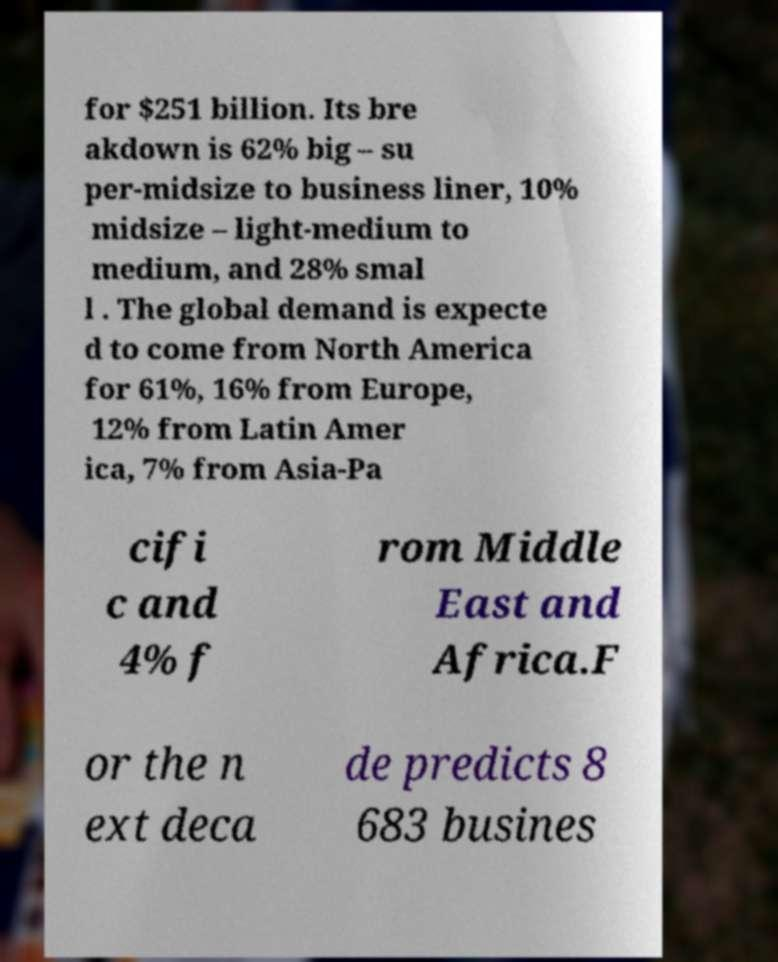Please read and relay the text visible in this image. What does it say? for $251 billion. Its bre akdown is 62% big – su per-midsize to business liner, 10% midsize – light-medium to medium, and 28% smal l . The global demand is expecte d to come from North America for 61%, 16% from Europe, 12% from Latin Amer ica, 7% from Asia-Pa cifi c and 4% f rom Middle East and Africa.F or the n ext deca de predicts 8 683 busines 